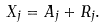<formula> <loc_0><loc_0><loc_500><loc_500>X _ { j } = A _ { j } + R _ { j } .</formula> 